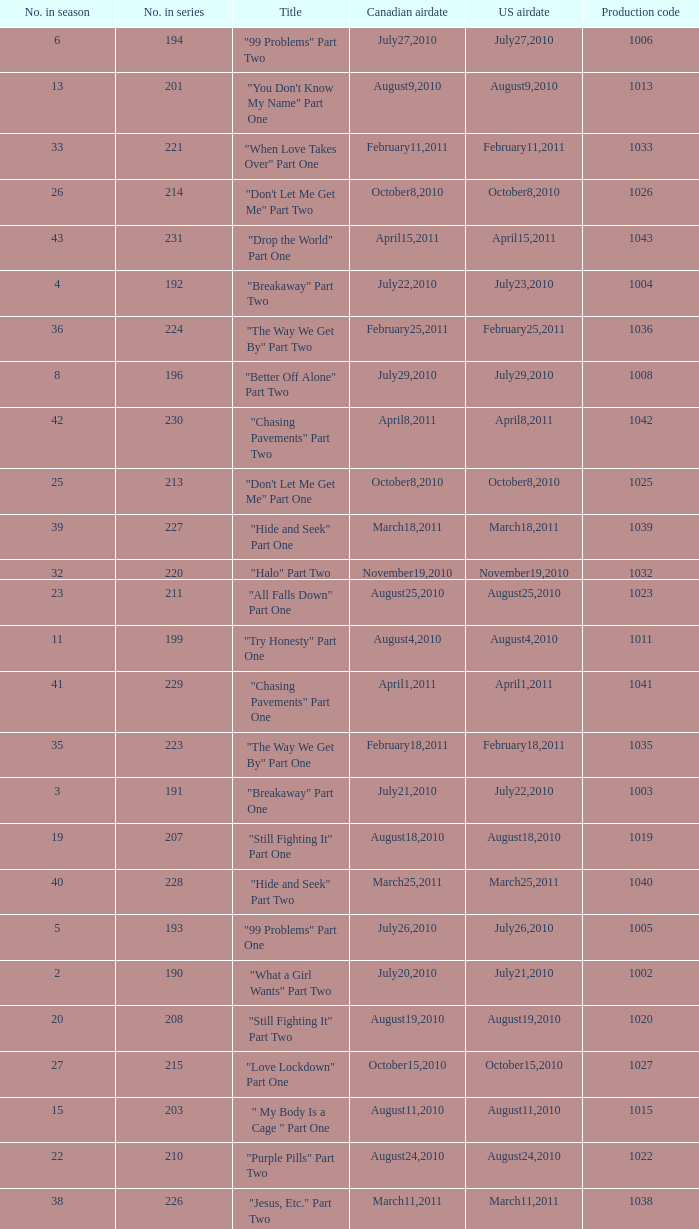I'm looking to parse the entire table for insights. Could you assist me with that? {'header': ['No. in season', 'No. in series', 'Title', 'Canadian airdate', 'US airdate', 'Production code'], 'rows': [['6', '194', '"99 Problems" Part Two', 'July27,2010', 'July27,2010', '1006'], ['13', '201', '"You Don\'t Know My Name" Part One', 'August9,2010', 'August9,2010', '1013'], ['33', '221', '"When Love Takes Over" Part One', 'February11,2011', 'February11,2011', '1033'], ['26', '214', '"Don\'t Let Me Get Me" Part Two', 'October8,2010', 'October8,2010', '1026'], ['43', '231', '"Drop the World" Part One', 'April15,2011', 'April15,2011', '1043'], ['4', '192', '"Breakaway" Part Two', 'July22,2010', 'July23,2010', '1004'], ['36', '224', '"The Way We Get By" Part Two', 'February25,2011', 'February25,2011', '1036'], ['8', '196', '"Better Off Alone" Part Two', 'July29,2010', 'July29,2010', '1008'], ['42', '230', '"Chasing Pavements" Part Two', 'April8,2011', 'April8,2011', '1042'], ['25', '213', '"Don\'t Let Me Get Me" Part One', 'October8,2010', 'October8,2010', '1025'], ['39', '227', '"Hide and Seek" Part One', 'March18,2011', 'March18,2011', '1039'], ['32', '220', '"Halo" Part Two', 'November19,2010', 'November19,2010', '1032'], ['23', '211', '"All Falls Down" Part One', 'August25,2010', 'August25,2010', '1023'], ['11', '199', '"Try Honesty" Part One', 'August4,2010', 'August4,2010', '1011'], ['41', '229', '"Chasing Pavements" Part One', 'April1,2011', 'April1,2011', '1041'], ['35', '223', '"The Way We Get By" Part One', 'February18,2011', 'February18,2011', '1035'], ['3', '191', '"Breakaway" Part One', 'July21,2010', 'July22,2010', '1003'], ['19', '207', '"Still Fighting It" Part One', 'August18,2010', 'August18,2010', '1019'], ['40', '228', '"Hide and Seek" Part Two', 'March25,2011', 'March25,2011', '1040'], ['5', '193', '"99 Problems" Part One', 'July26,2010', 'July26,2010', '1005'], ['2', '190', '"What a Girl Wants" Part Two', 'July20,2010', 'July21,2010', '1002'], ['20', '208', '"Still Fighting It" Part Two', 'August19,2010', 'August19,2010', '1020'], ['27', '215', '"Love Lockdown" Part One', 'October15,2010', 'October15,2010', '1027'], ['15', '203', '" My Body Is a Cage " Part One', 'August11,2010', 'August11,2010', '1015'], ['22', '210', '"Purple Pills" Part Two', 'August24,2010', 'August24,2010', '1022'], ['38', '226', '"Jesus, Etc." Part Two', 'March11,2011', 'March11,2011', '1038'], ['30', '218', '"Umbrella" Part Two', 'November5,2010', 'November5,2010', '1030'], ['34', '222', '"When Love Takes Over" Part Two', 'February11,2011', 'February11,2011', '1034'], ['37', '225', '"Jesus, Etc." Part One', 'March4,2011', 'March4,2011', '1037'], ['18', '206', '"Tears Dry on Their Own" Part Two', 'August17,2010', 'August17,2010', '1018'], ['12', '200', '"Try Honesty" Part Two', 'August5,2010', 'August5,2010', '1012'], ['31', '219', '"Halo" Part One', 'November12,2010', 'November12,2010', '1031'], ['28', '216', '"Love Lockdown" Part Two', 'October22,2010', 'October22,2010', '1028'], ['24', '212', '"All Falls Down" Part Two', 'August26,2010', 'August26,2010', '1024'], ['21', '209', '"Purple Pills" Part One', 'August23,2010', 'August23,2010', '1021'], ['16', '204', '" My Body Is a Cage " Part Two', 'August12,2010', 'August12,2010', '1016'], ['1', '189', '"What a Girl Wants" Part One', 'July19,2010', 'July20,2010', '1001'], ['7', '195', '"Better Off Alone" Part One', 'July28,2010', 'July28,2010', '1007'], ['29', '217', '"Umbrella" Part One', 'October29,2010', 'October29,2010', '1029'], ['17', '205', '"Tears Dry on Their Own" Part One', 'August16,2010', 'August16,2010', '1017'], ['14', '202', '"You Don\'t Know My Name" Part Two', 'August10,2010', 'August10,2010', '1014']]} What was the us airdate of "love lockdown" part one? October15,2010. 